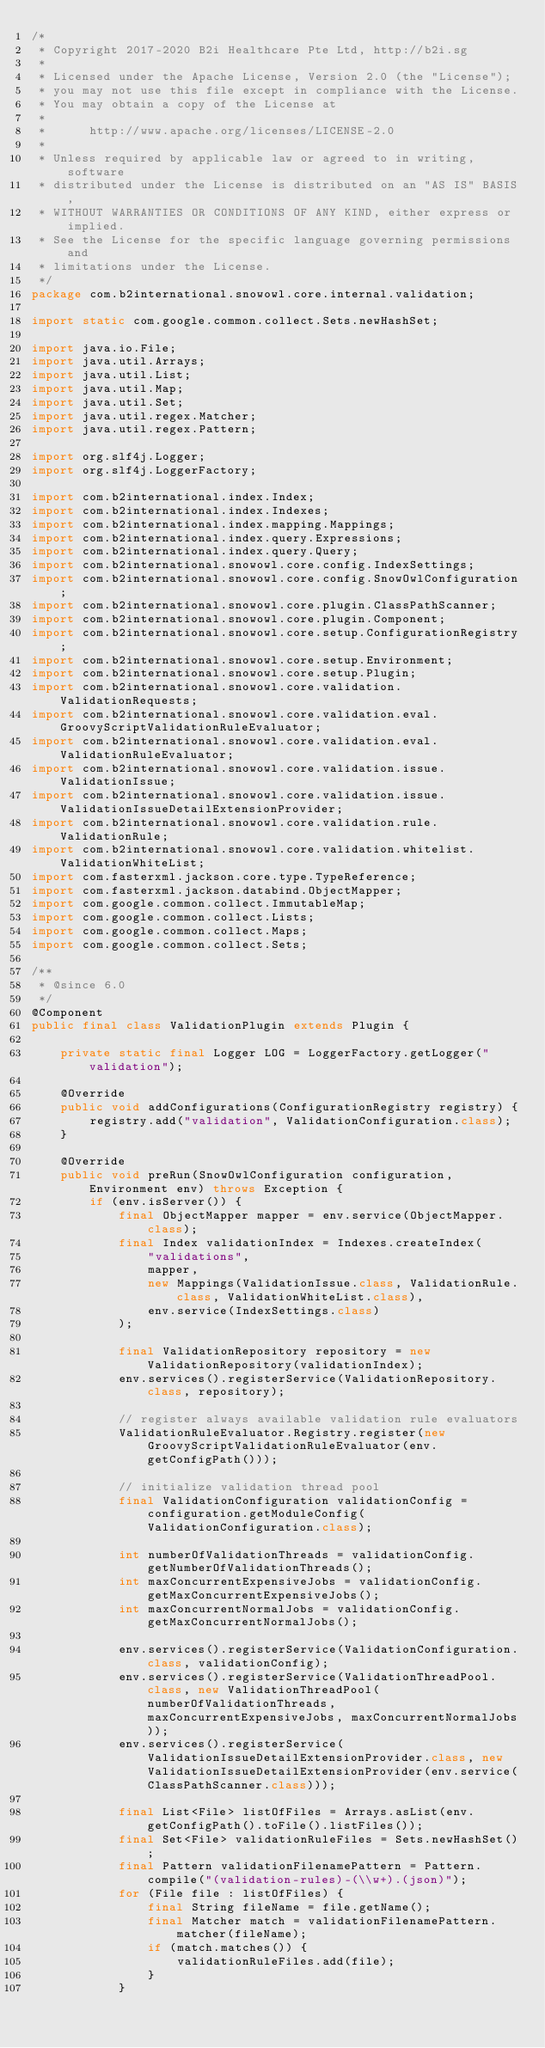Convert code to text. <code><loc_0><loc_0><loc_500><loc_500><_Java_>/*
 * Copyright 2017-2020 B2i Healthcare Pte Ltd, http://b2i.sg
 * 
 * Licensed under the Apache License, Version 2.0 (the "License");
 * you may not use this file except in compliance with the License.
 * You may obtain a copy of the License at
 *
 *      http://www.apache.org/licenses/LICENSE-2.0
 *
 * Unless required by applicable law or agreed to in writing, software
 * distributed under the License is distributed on an "AS IS" BASIS,
 * WITHOUT WARRANTIES OR CONDITIONS OF ANY KIND, either express or implied.
 * See the License for the specific language governing permissions and
 * limitations under the License.
 */
package com.b2international.snowowl.core.internal.validation;

import static com.google.common.collect.Sets.newHashSet;

import java.io.File;
import java.util.Arrays;
import java.util.List;
import java.util.Map;
import java.util.Set;
import java.util.regex.Matcher;
import java.util.regex.Pattern;

import org.slf4j.Logger;
import org.slf4j.LoggerFactory;

import com.b2international.index.Index;
import com.b2international.index.Indexes;
import com.b2international.index.mapping.Mappings;
import com.b2international.index.query.Expressions;
import com.b2international.index.query.Query;
import com.b2international.snowowl.core.config.IndexSettings;
import com.b2international.snowowl.core.config.SnowOwlConfiguration;
import com.b2international.snowowl.core.plugin.ClassPathScanner;
import com.b2international.snowowl.core.plugin.Component;
import com.b2international.snowowl.core.setup.ConfigurationRegistry;
import com.b2international.snowowl.core.setup.Environment;
import com.b2international.snowowl.core.setup.Plugin;
import com.b2international.snowowl.core.validation.ValidationRequests;
import com.b2international.snowowl.core.validation.eval.GroovyScriptValidationRuleEvaluator;
import com.b2international.snowowl.core.validation.eval.ValidationRuleEvaluator;
import com.b2international.snowowl.core.validation.issue.ValidationIssue;
import com.b2international.snowowl.core.validation.issue.ValidationIssueDetailExtensionProvider;
import com.b2international.snowowl.core.validation.rule.ValidationRule;
import com.b2international.snowowl.core.validation.whitelist.ValidationWhiteList;
import com.fasterxml.jackson.core.type.TypeReference;
import com.fasterxml.jackson.databind.ObjectMapper;
import com.google.common.collect.ImmutableMap;
import com.google.common.collect.Lists;
import com.google.common.collect.Maps;
import com.google.common.collect.Sets;

/**
 * @since 6.0
 */
@Component
public final class ValidationPlugin extends Plugin {

	private static final Logger LOG = LoggerFactory.getLogger("validation");
	
	@Override
	public void addConfigurations(ConfigurationRegistry registry) {
		registry.add("validation", ValidationConfiguration.class);
	}
	
	@Override
	public void preRun(SnowOwlConfiguration configuration, Environment env) throws Exception {
		if (env.isServer()) {
			final ObjectMapper mapper = env.service(ObjectMapper.class);
			final Index validationIndex = Indexes.createIndex(
				"validations", 
				mapper, 
				new Mappings(ValidationIssue.class, ValidationRule.class, ValidationWhiteList.class), 
				env.service(IndexSettings.class)
			);
			
			final ValidationRepository repository = new ValidationRepository(validationIndex);
			env.services().registerService(ValidationRepository.class, repository);
			
			// register always available validation rule evaluators
			ValidationRuleEvaluator.Registry.register(new GroovyScriptValidationRuleEvaluator(env.getConfigPath()));
			
			// initialize validation thread pool
			final ValidationConfiguration validationConfig = configuration.getModuleConfig(ValidationConfiguration.class);

			int numberOfValidationThreads = validationConfig.getNumberOfValidationThreads();
			int maxConcurrentExpensiveJobs = validationConfig.getMaxConcurrentExpensiveJobs();
			int maxConcurrentNormalJobs = validationConfig.getMaxConcurrentNormalJobs();
			
			env.services().registerService(ValidationConfiguration.class, validationConfig);
			env.services().registerService(ValidationThreadPool.class, new ValidationThreadPool(numberOfValidationThreads, maxConcurrentExpensiveJobs, maxConcurrentNormalJobs));
			env.services().registerService(ValidationIssueDetailExtensionProvider.class, new ValidationIssueDetailExtensionProvider(env.service(ClassPathScanner.class)));
			
			final List<File> listOfFiles = Arrays.asList(env.getConfigPath().toFile().listFiles());
			final Set<File> validationRuleFiles = Sets.newHashSet();
			final Pattern validationFilenamePattern = Pattern.compile("(validation-rules)-(\\w+).(json)");
			for (File file : listOfFiles) {
				final String fileName = file.getName();
				final Matcher match = validationFilenamePattern.matcher(fileName);
				if (match.matches()) {
					validationRuleFiles.add(file);
				}
			}
			</code> 